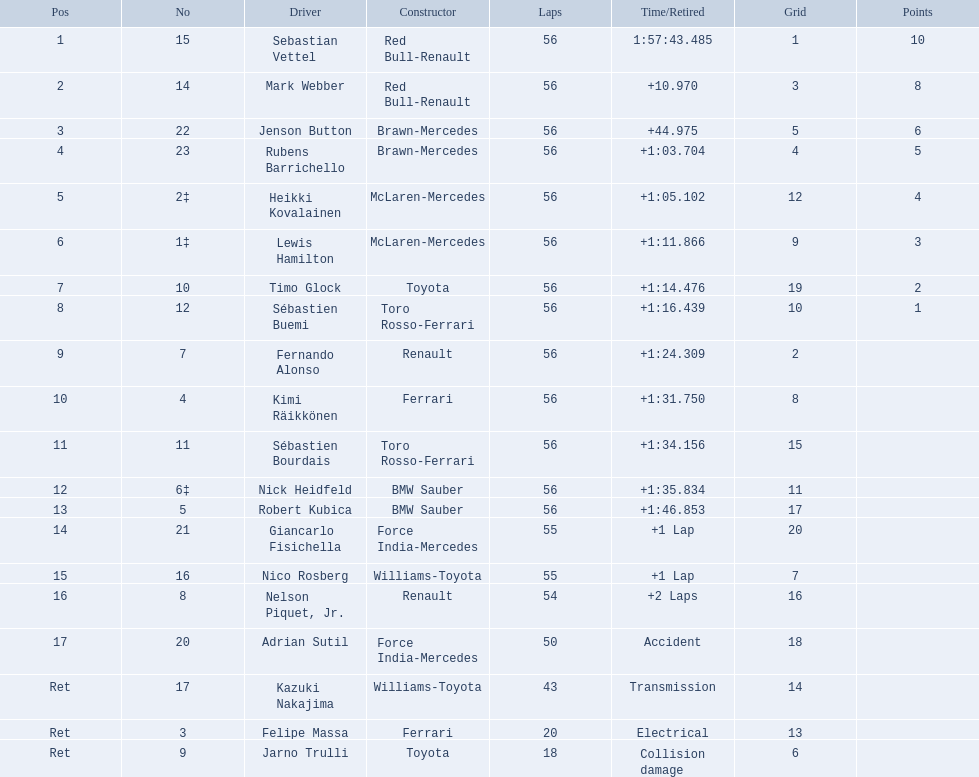Which drive retired because of electrical issues? Felipe Massa. Which driver retired due to accident? Adrian Sutil. Which driver retired due to collision damage? Jarno Trulli. 